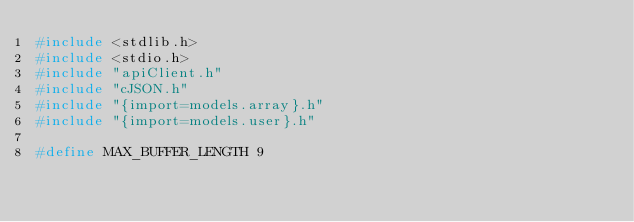<code> <loc_0><loc_0><loc_500><loc_500><_C_>#include <stdlib.h>
#include <stdio.h>
#include "apiClient.h"
#include "cJSON.h"
#include "{import=models.array}.h"
#include "{import=models.user}.h"

#define MAX_BUFFER_LENGTH 9
</code> 